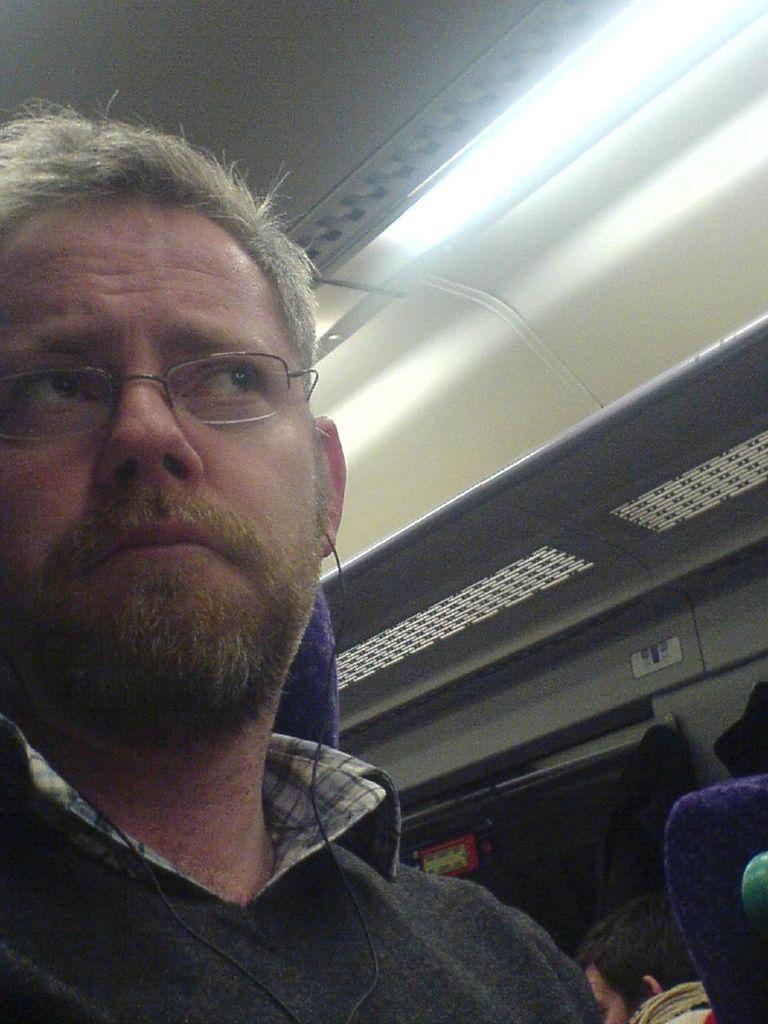How would you summarize this image in a sentence or two? In this picture I can see the inside view of a vehicle, there are two persons sitting on the seats , there is a light and a window. 